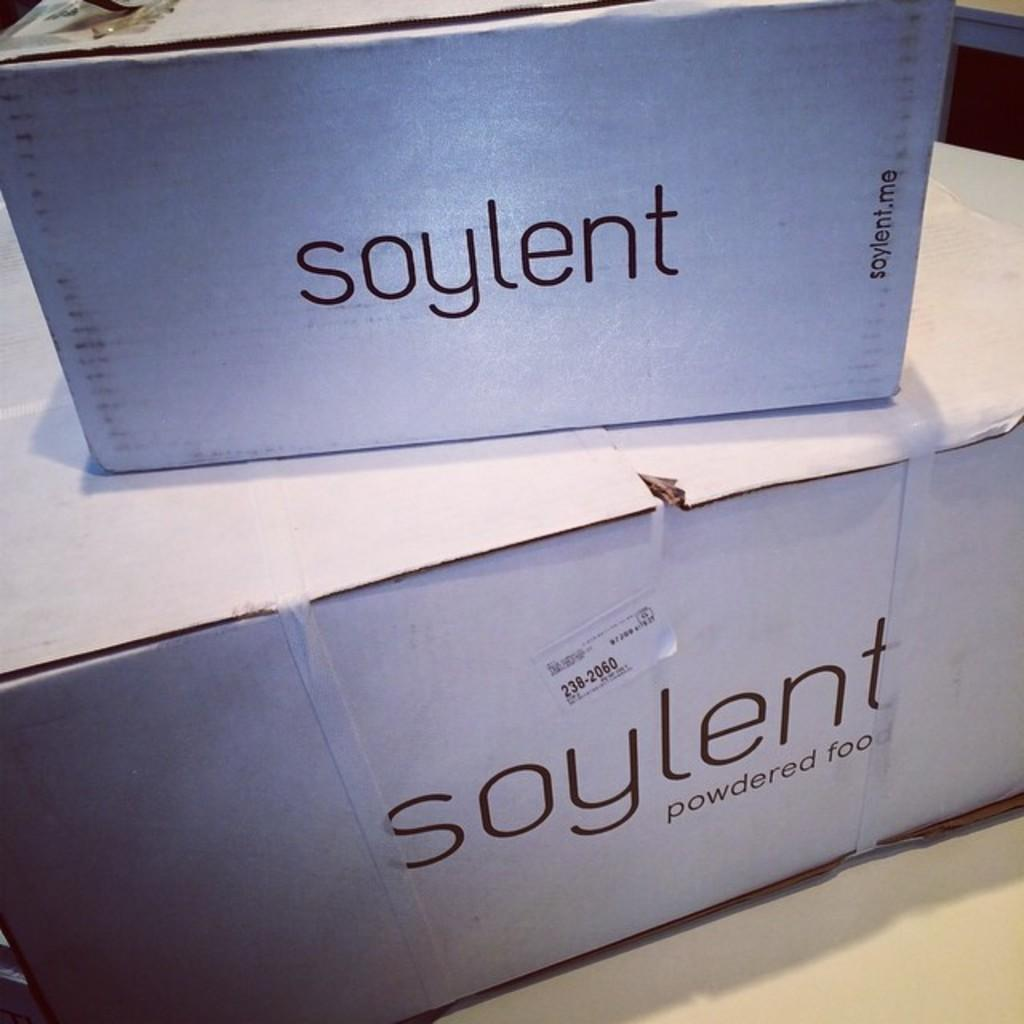Provide a one-sentence caption for the provided image. Two white boxes of a powdered food product called soylent. 